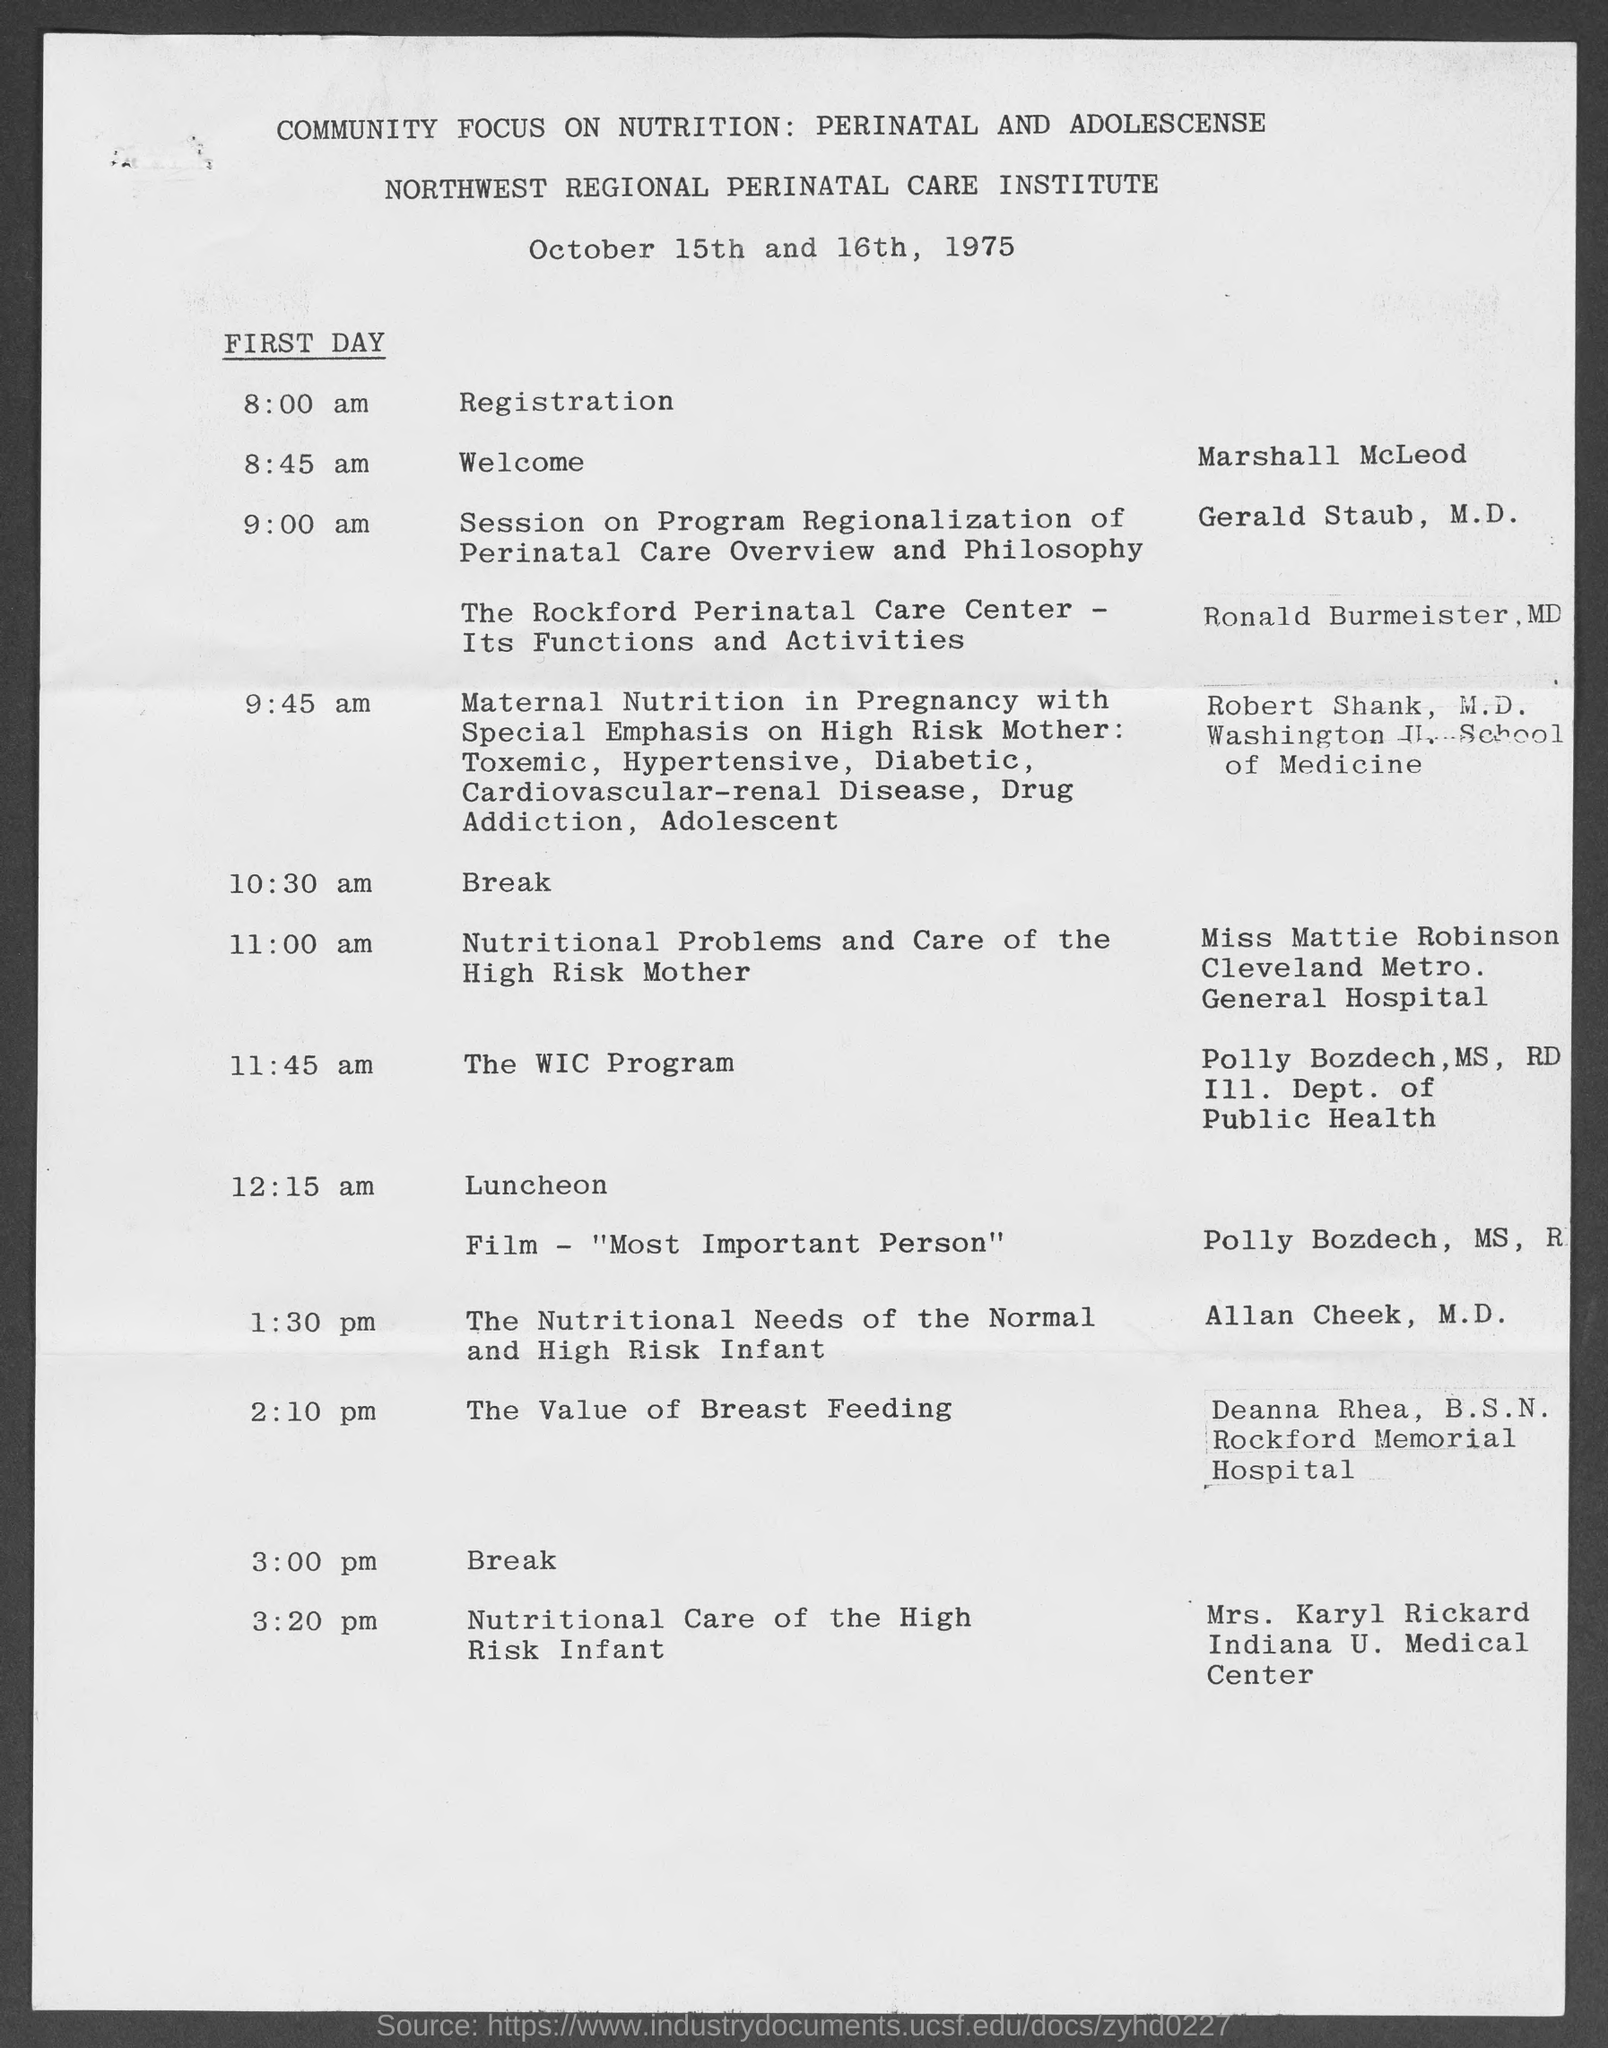Which institute is mentioned?
Ensure brevity in your answer.  Northwest regional perinatal care institute. When is the program?
Provide a succinct answer. October 15th and 16th, 1975. Who will welcome at 8:45 am on first day?
Offer a terse response. Marshall McLeod. Which film is to be shown?
Offer a terse response. "Most Important Person". From which hospital is Deanna Rhea, B.S.N. from?
Your answer should be very brief. Rockford memorial hospital. What is the topic of Mrs. Karyl Rickard?
Your answer should be very brief. Nutritional Care of the High Risk Infant. 